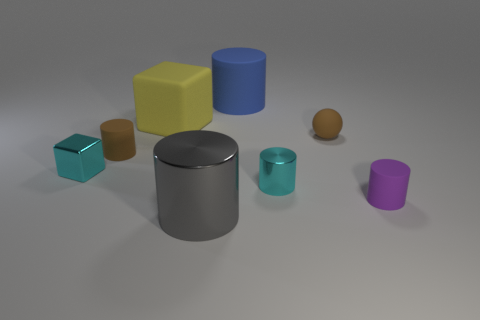Subtract all purple cylinders. How many cylinders are left? 4 Subtract all small purple cylinders. How many cylinders are left? 4 Subtract 1 cylinders. How many cylinders are left? 4 Subtract all yellow cylinders. Subtract all cyan cubes. How many cylinders are left? 5 Add 1 tiny red rubber objects. How many objects exist? 9 Subtract all balls. How many objects are left? 7 Subtract 1 brown spheres. How many objects are left? 7 Subtract all big yellow shiny cylinders. Subtract all gray cylinders. How many objects are left? 7 Add 5 tiny rubber objects. How many tiny rubber objects are left? 8 Add 6 large matte cubes. How many large matte cubes exist? 7 